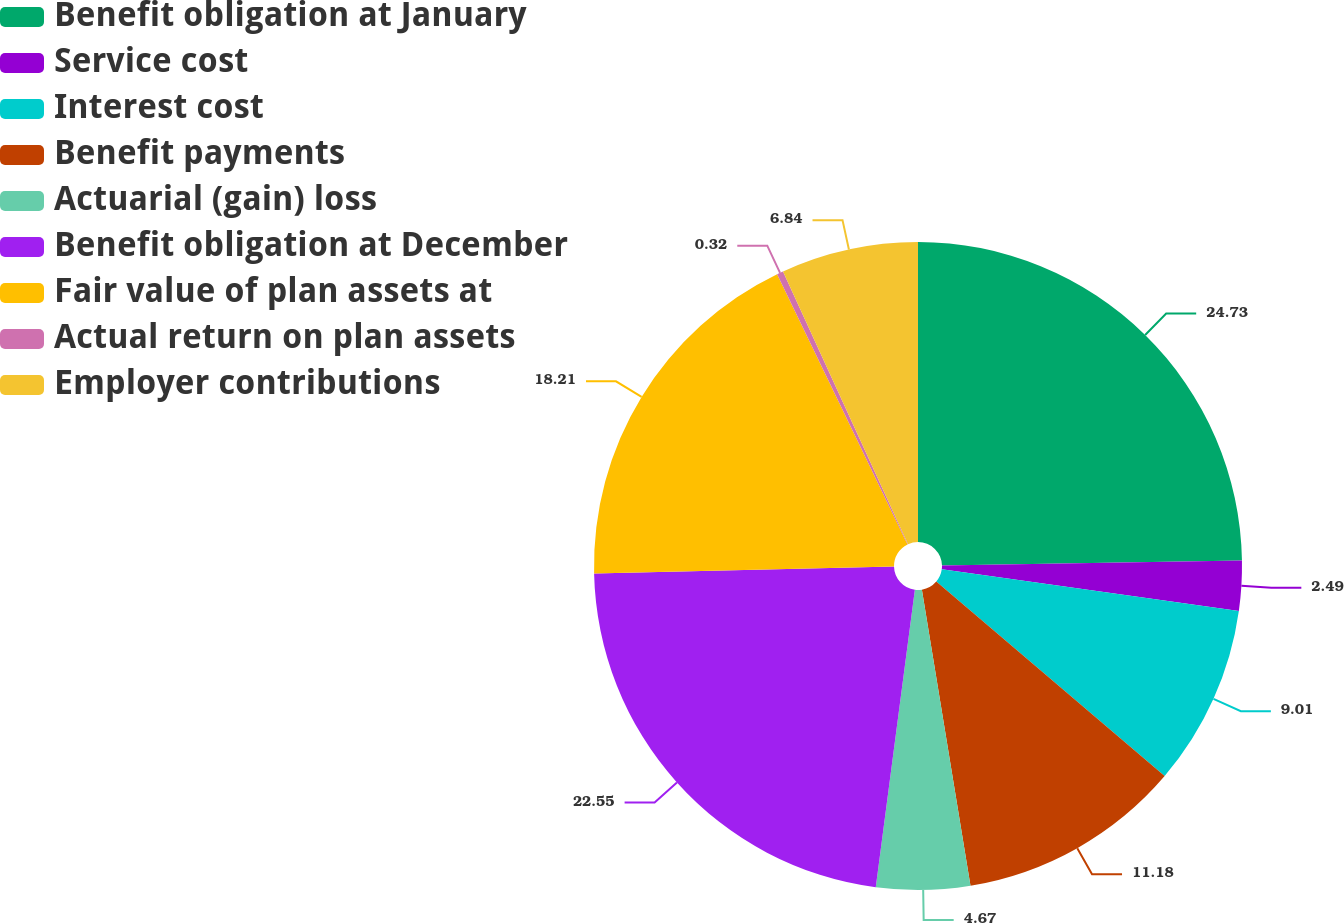Convert chart. <chart><loc_0><loc_0><loc_500><loc_500><pie_chart><fcel>Benefit obligation at January<fcel>Service cost<fcel>Interest cost<fcel>Benefit payments<fcel>Actuarial (gain) loss<fcel>Benefit obligation at December<fcel>Fair value of plan assets at<fcel>Actual return on plan assets<fcel>Employer contributions<nl><fcel>24.73%<fcel>2.49%<fcel>9.01%<fcel>11.18%<fcel>4.67%<fcel>22.55%<fcel>18.21%<fcel>0.32%<fcel>6.84%<nl></chart> 